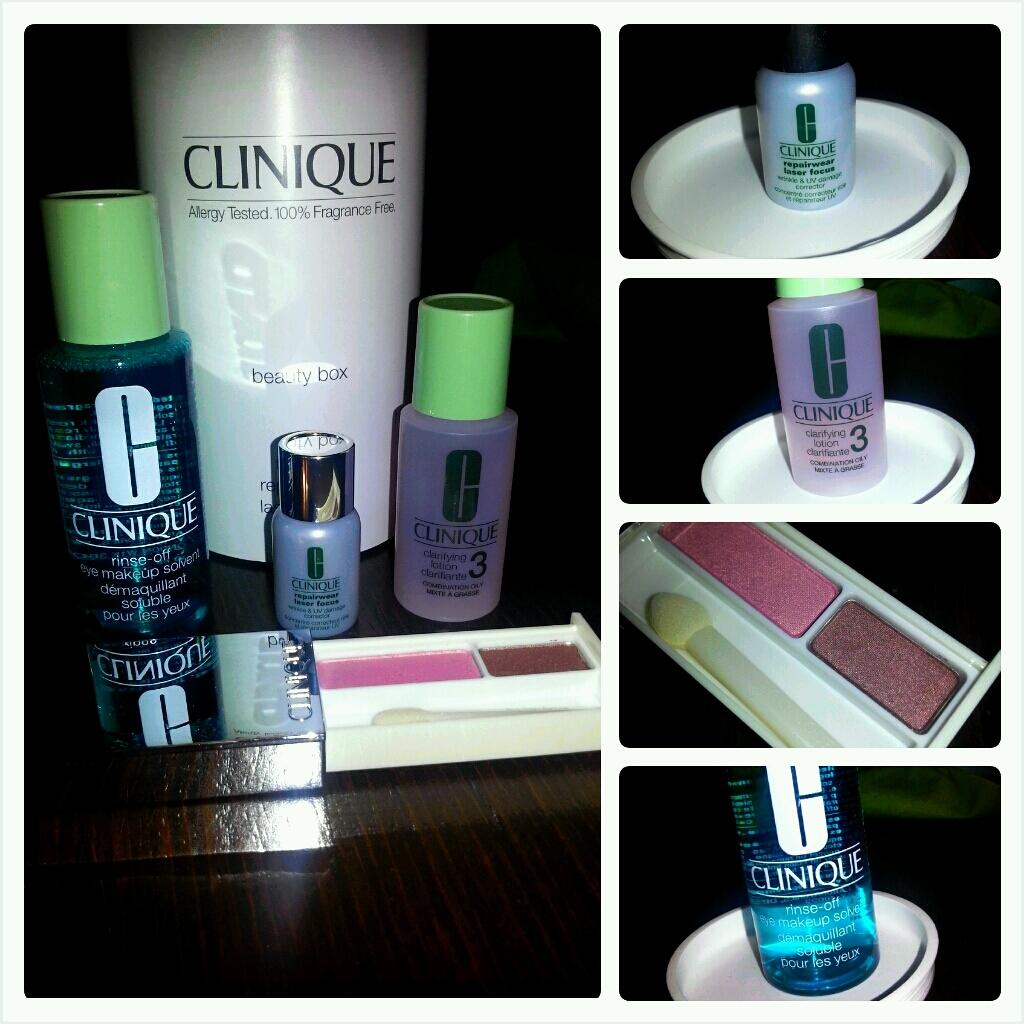<image>
Provide a brief description of the given image. clinique make up products like clarifying lotions and rise of eye makeup remover 